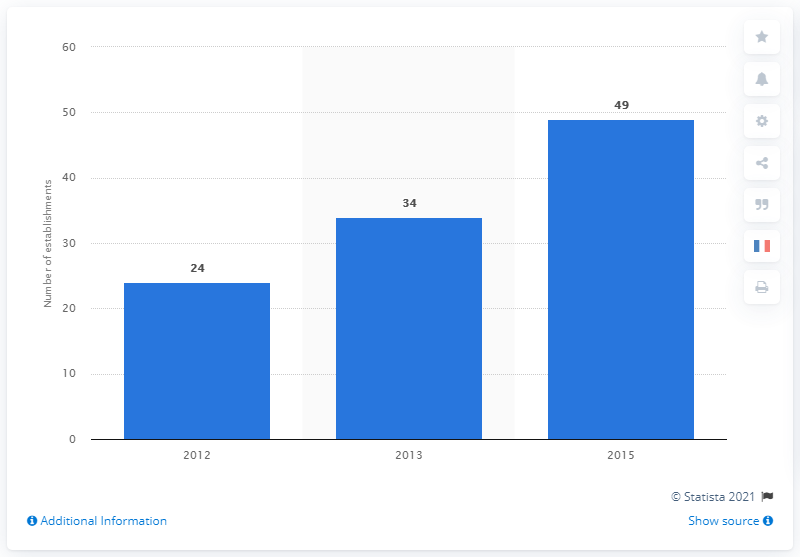Identify some key points in this picture. There were 49 Islamic faith schools in France in 2015. 